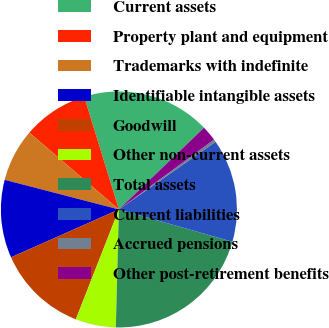Convert chart. <chart><loc_0><loc_0><loc_500><loc_500><pie_chart><fcel>Current assets<fcel>Property plant and equipment<fcel>Trademarks with indefinite<fcel>Identifiable intangible assets<fcel>Goodwill<fcel>Other non-current assets<fcel>Total assets<fcel>Current liabilities<fcel>Accrued pensions<fcel>Other post-retirement benefits<nl><fcel>17.57%<fcel>8.97%<fcel>7.25%<fcel>10.69%<fcel>12.41%<fcel>5.53%<fcel>21.01%<fcel>14.13%<fcel>0.37%<fcel>2.09%<nl></chart> 